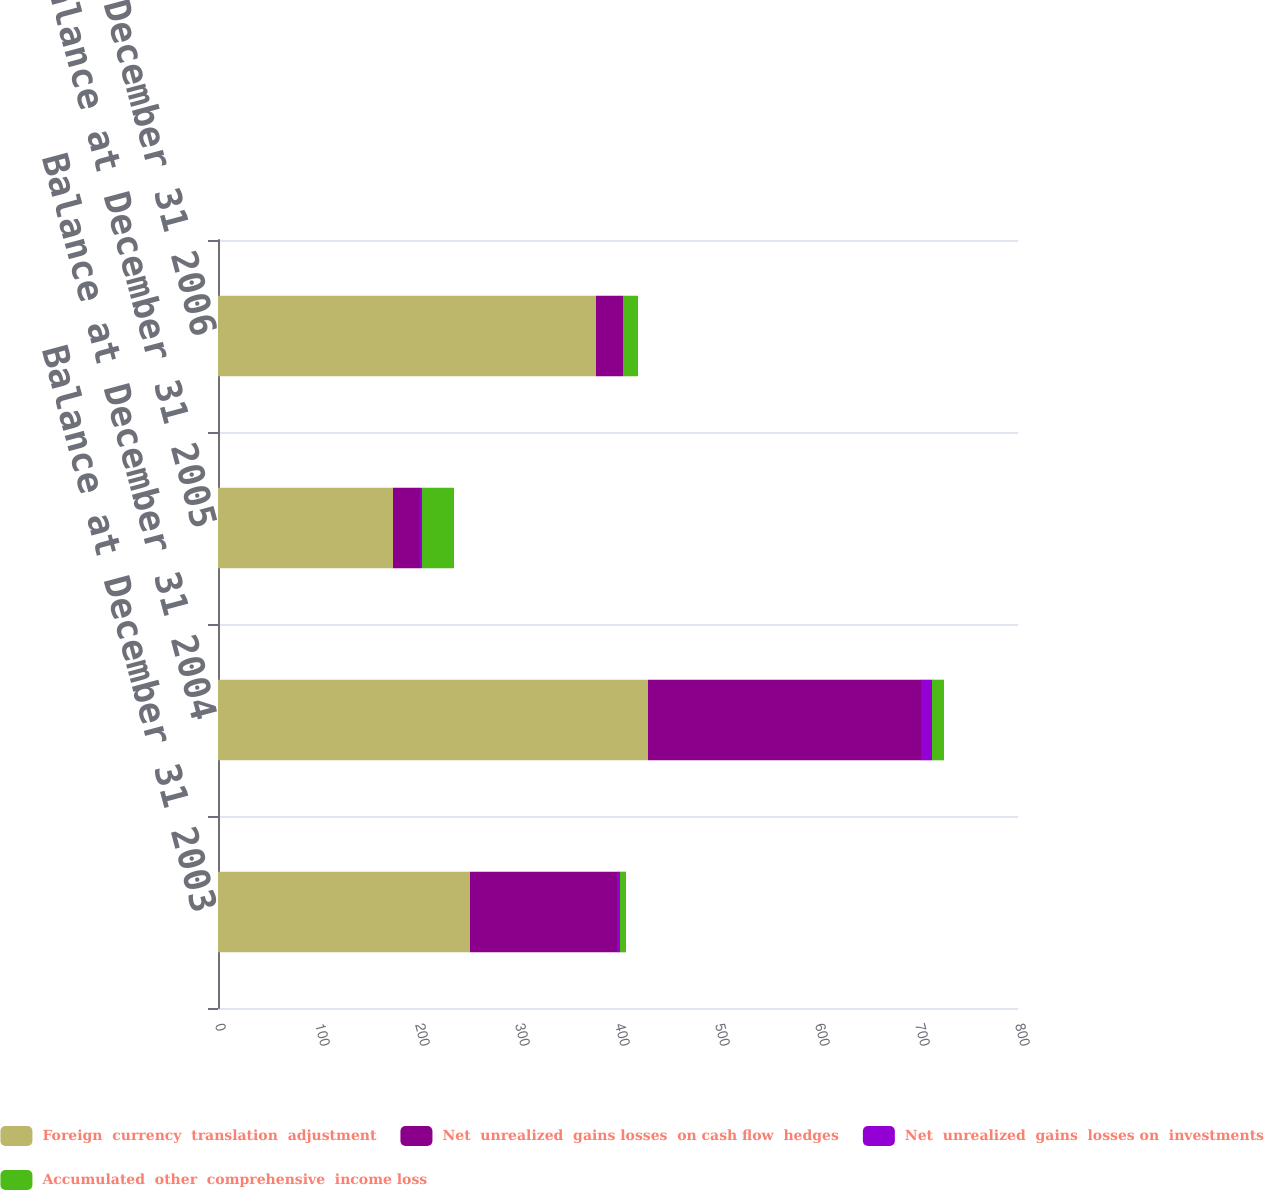<chart> <loc_0><loc_0><loc_500><loc_500><stacked_bar_chart><ecel><fcel>Balance at December 31 2003<fcel>Balance at December 31 2004<fcel>Balance at December 31 2005<fcel>Balance at December 31 2006<nl><fcel>Foreign  currency  translation  adjustment<fcel>252<fcel>430<fcel>175<fcel>378<nl><fcel>Net  unrealized  gains losses  on cash flow  hedges<fcel>147<fcel>273<fcel>27<fcel>27<nl><fcel>Net  unrealized  gains  losses on  investments<fcel>3<fcel>11<fcel>2<fcel>0<nl><fcel>Accumulated  other  comprehensive  income loss<fcel>6<fcel>12<fcel>32<fcel>15<nl></chart> 